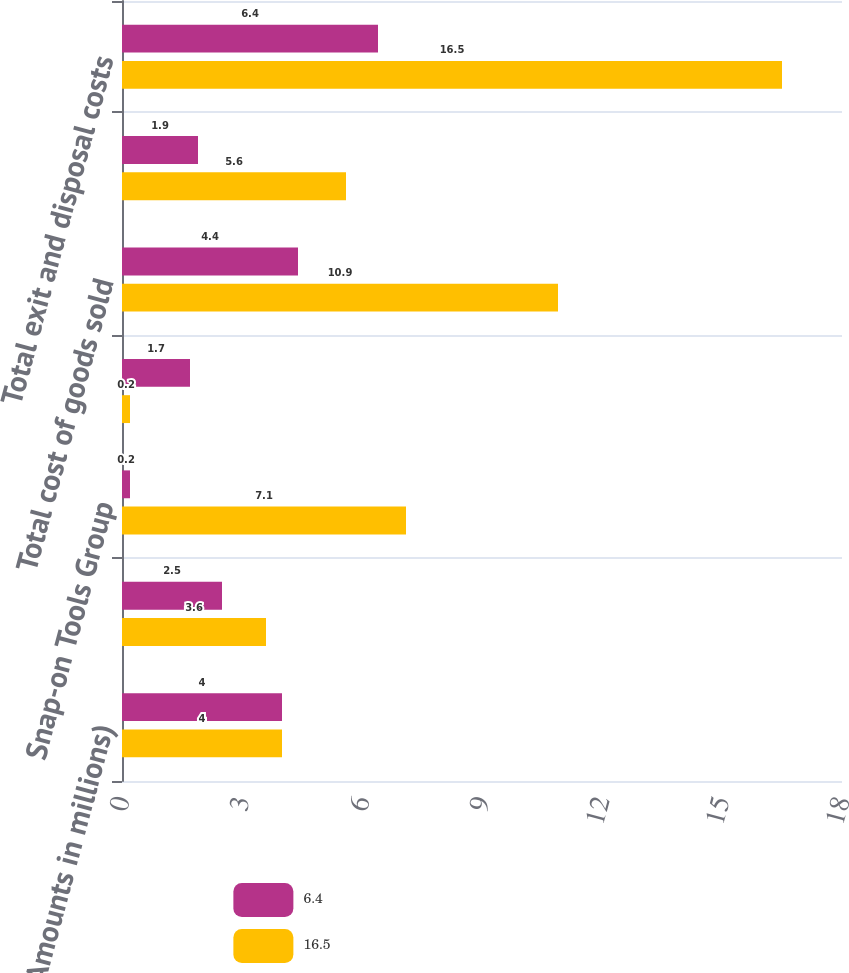Convert chart. <chart><loc_0><loc_0><loc_500><loc_500><stacked_bar_chart><ecel><fcel>(Amounts in millions)<fcel>Commercial & Industrial Group<fcel>Snap-on Tools Group<fcel>Repair Systems & Information<fcel>Total cost of goods sold<fcel>Total operating expenses<fcel>Total exit and disposal costs<nl><fcel>6.4<fcel>4<fcel>2.5<fcel>0.2<fcel>1.7<fcel>4.4<fcel>1.9<fcel>6.4<nl><fcel>16.5<fcel>4<fcel>3.6<fcel>7.1<fcel>0.2<fcel>10.9<fcel>5.6<fcel>16.5<nl></chart> 